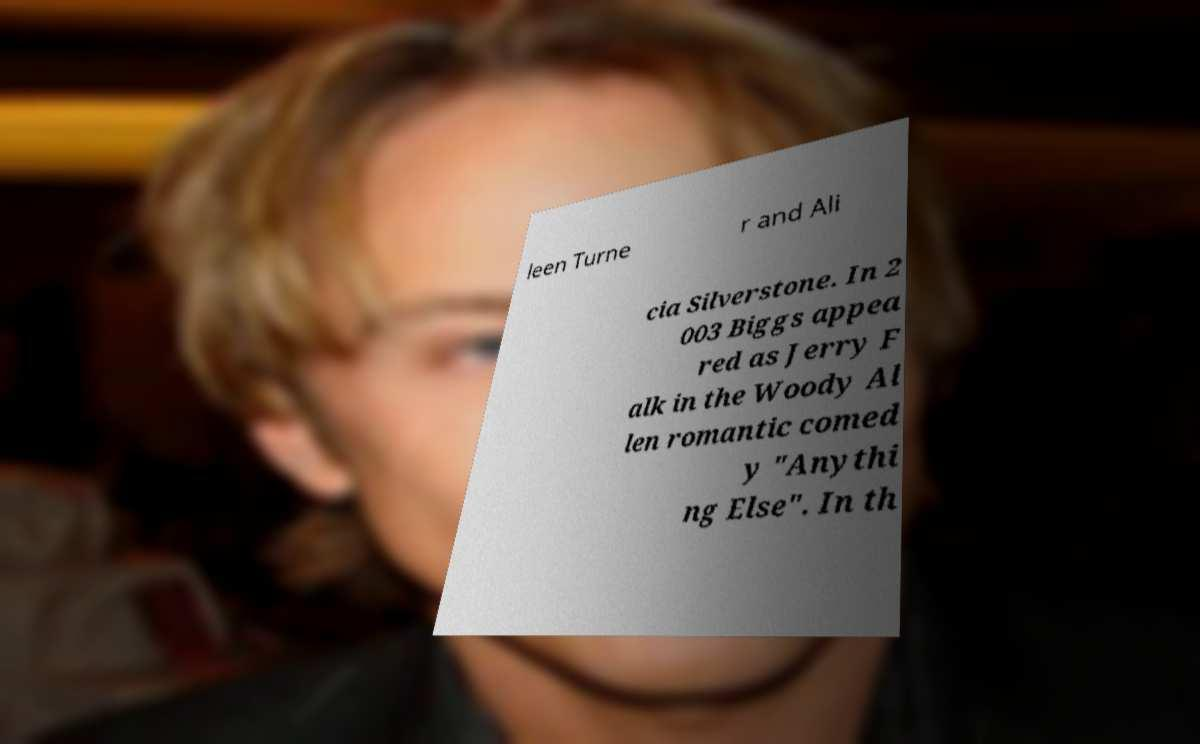Can you accurately transcribe the text from the provided image for me? leen Turne r and Ali cia Silverstone. In 2 003 Biggs appea red as Jerry F alk in the Woody Al len romantic comed y "Anythi ng Else". In th 